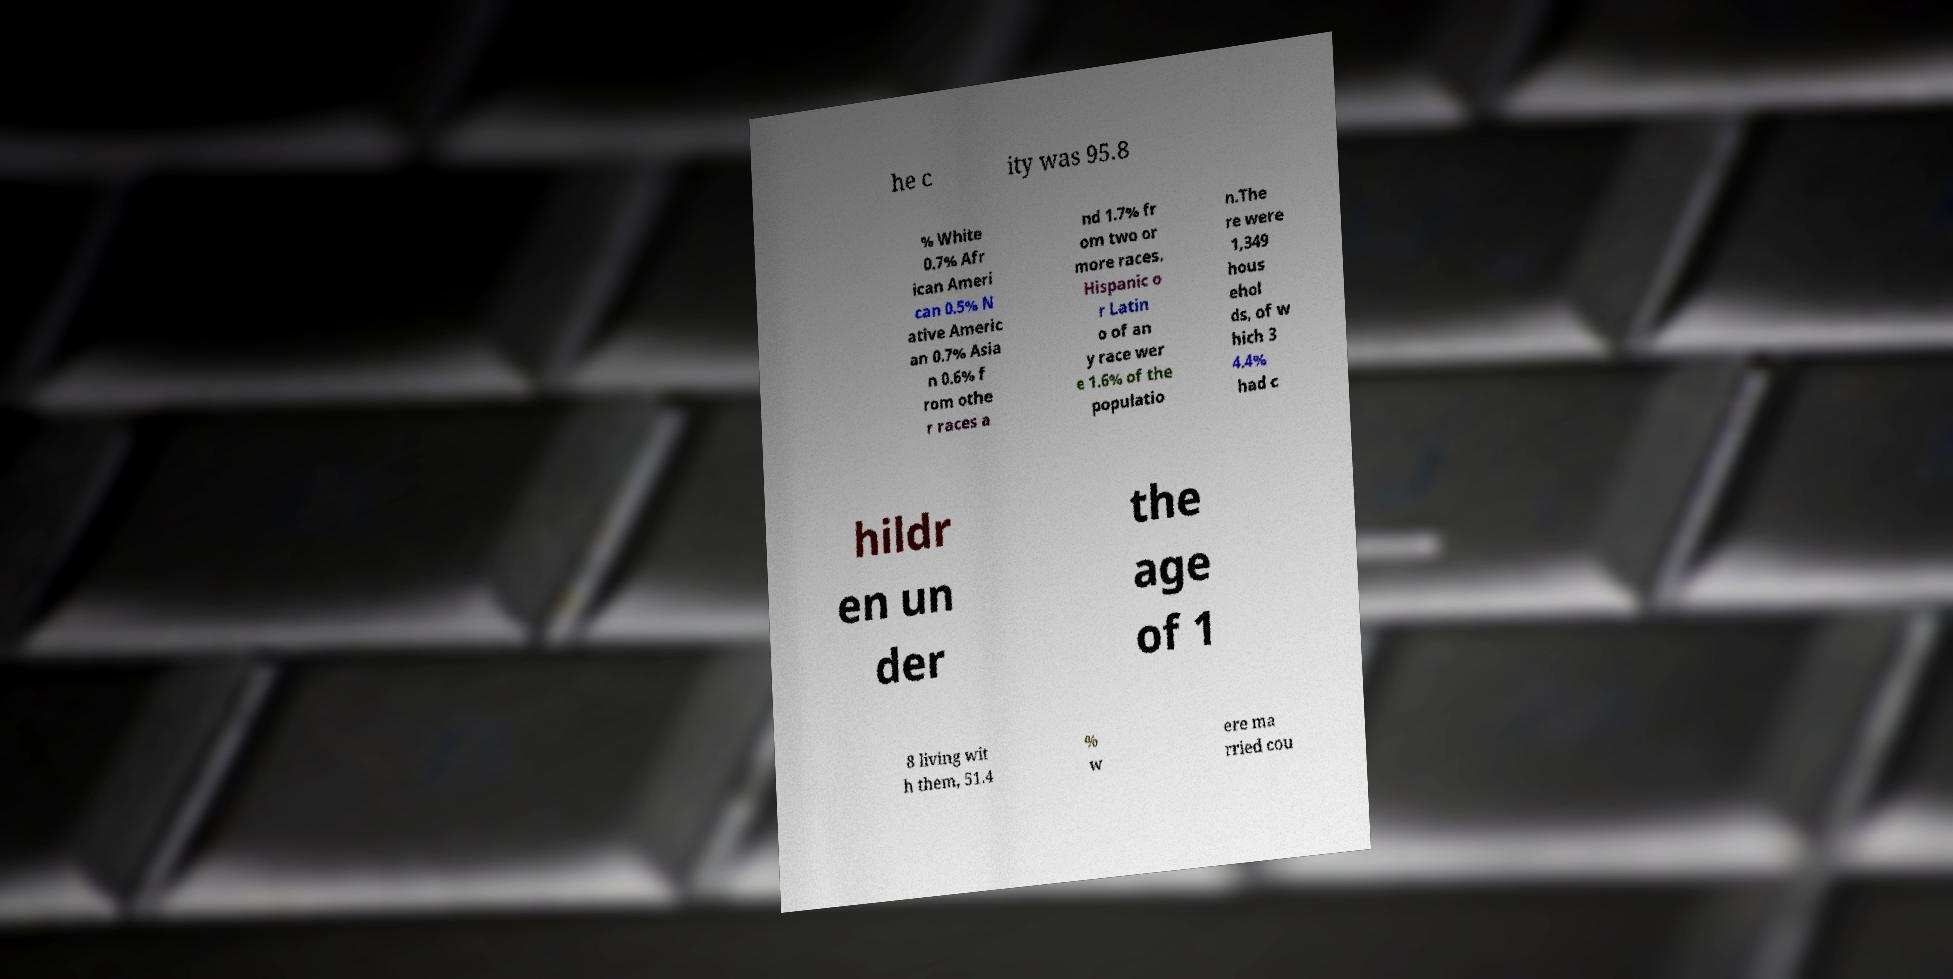Could you extract and type out the text from this image? he c ity was 95.8 % White 0.7% Afr ican Ameri can 0.5% N ative Americ an 0.7% Asia n 0.6% f rom othe r races a nd 1.7% fr om two or more races. Hispanic o r Latin o of an y race wer e 1.6% of the populatio n.The re were 1,349 hous ehol ds, of w hich 3 4.4% had c hildr en un der the age of 1 8 living wit h them, 51.4 % w ere ma rried cou 